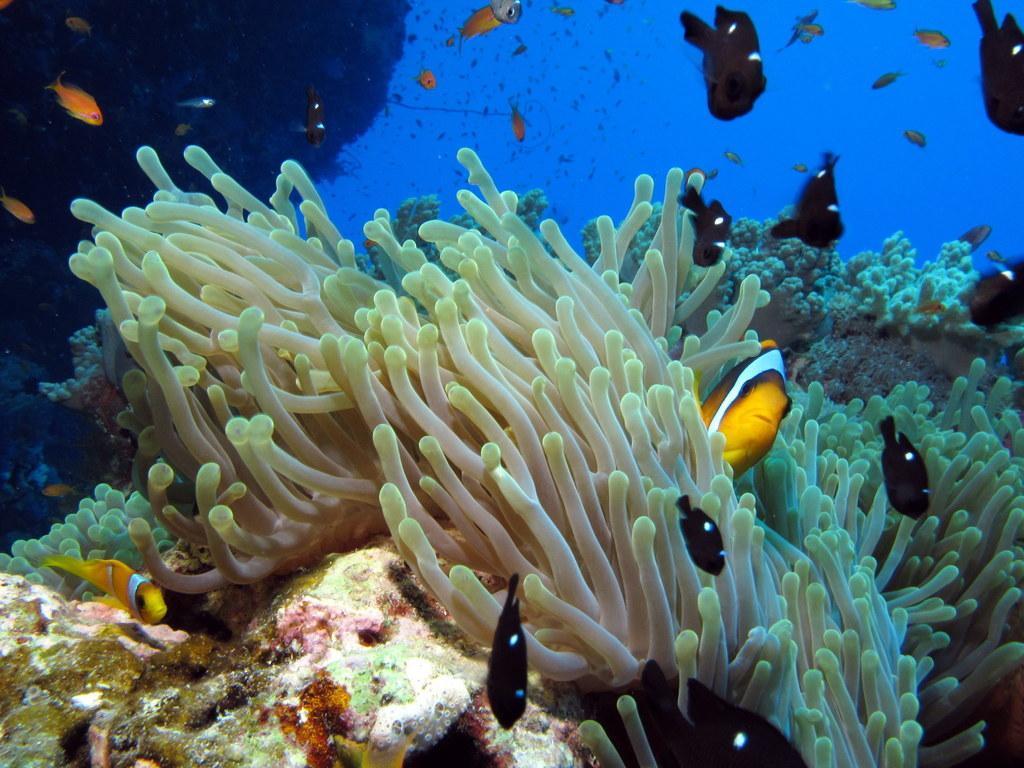How would you summarize this image in a sentence or two? In this picture I can see the inside view of water and I can see few sea plants and I see number of fish. 